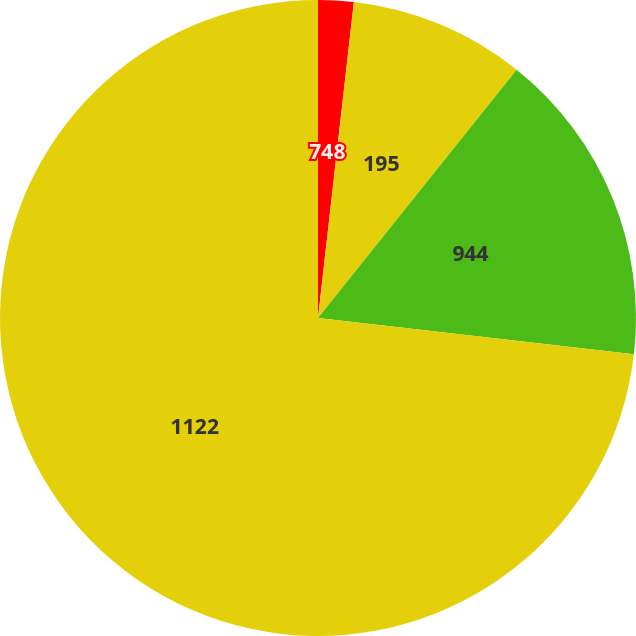<chart> <loc_0><loc_0><loc_500><loc_500><pie_chart><fcel>748<fcel>195<fcel>944<fcel>1122<nl><fcel>1.8%<fcel>8.94%<fcel>16.08%<fcel>73.18%<nl></chart> 